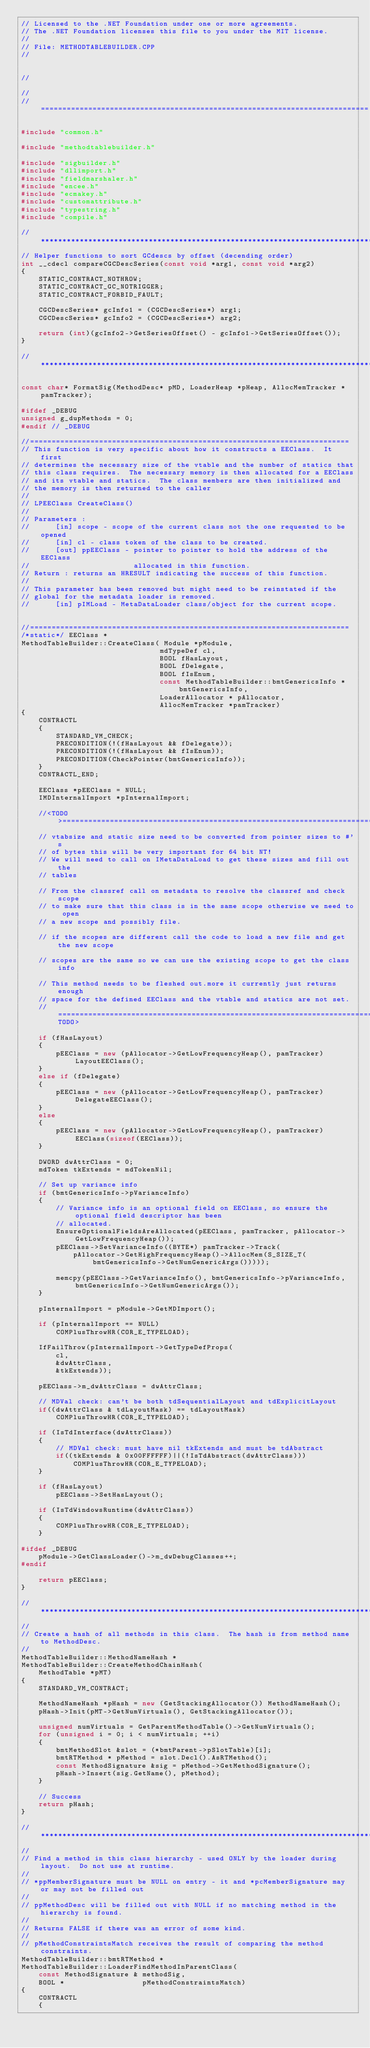Convert code to text. <code><loc_0><loc_0><loc_500><loc_500><_C++_>// Licensed to the .NET Foundation under one or more agreements.
// The .NET Foundation licenses this file to you under the MIT license.
//
// File: METHODTABLEBUILDER.CPP
//


//

//
// ============================================================================

#include "common.h"

#include "methodtablebuilder.h"

#include "sigbuilder.h"
#include "dllimport.h"
#include "fieldmarshaler.h"
#include "encee.h"
#include "ecmakey.h"
#include "customattribute.h"
#include "typestring.h"
#include "compile.h"

//*******************************************************************************
// Helper functions to sort GCdescs by offset (decending order)
int __cdecl compareCGCDescSeries(const void *arg1, const void *arg2)
{
    STATIC_CONTRACT_NOTHROW;
    STATIC_CONTRACT_GC_NOTRIGGER;
    STATIC_CONTRACT_FORBID_FAULT;

    CGCDescSeries* gcInfo1 = (CGCDescSeries*) arg1;
    CGCDescSeries* gcInfo2 = (CGCDescSeries*) arg2;

    return (int)(gcInfo2->GetSeriesOffset() - gcInfo1->GetSeriesOffset());
}

//*******************************************************************************

const char* FormatSig(MethodDesc* pMD, LoaderHeap *pHeap, AllocMemTracker *pamTracker);

#ifdef _DEBUG
unsigned g_dupMethods = 0;
#endif // _DEBUG

//==========================================================================
// This function is very specific about how it constructs a EEClass.  It first
// determines the necessary size of the vtable and the number of statics that
// this class requires.  The necessary memory is then allocated for a EEClass
// and its vtable and statics.  The class members are then initialized and
// the memory is then returned to the caller
//
// LPEEClass CreateClass()
//
// Parameters :
//      [in] scope - scope of the current class not the one requested to be opened
//      [in] cl - class token of the class to be created.
//      [out] ppEEClass - pointer to pointer to hold the address of the EEClass
//                        allocated in this function.
// Return : returns an HRESULT indicating the success of this function.
//
// This parameter has been removed but might need to be reinstated if the
// global for the metadata loader is removed.
//      [in] pIMLoad - MetaDataLoader class/object for the current scope.


//==========================================================================
/*static*/ EEClass *
MethodTableBuilder::CreateClass( Module *pModule,
                                mdTypeDef cl,
                                BOOL fHasLayout,
                                BOOL fDelegate,
                                BOOL fIsEnum,
                                const MethodTableBuilder::bmtGenericsInfo *bmtGenericsInfo,
                                LoaderAllocator * pAllocator,
                                AllocMemTracker *pamTracker)
{
    CONTRACTL
    {
        STANDARD_VM_CHECK;
        PRECONDITION(!(fHasLayout && fDelegate));
        PRECONDITION(!(fHasLayout && fIsEnum));
        PRECONDITION(CheckPointer(bmtGenericsInfo));
    }
    CONTRACTL_END;

    EEClass *pEEClass = NULL;
    IMDInternalImport *pInternalImport;

    //<TODO>============================================================================
    // vtabsize and static size need to be converted from pointer sizes to #'s
    // of bytes this will be very important for 64 bit NT!
    // We will need to call on IMetaDataLoad to get these sizes and fill out the
    // tables

    // From the classref call on metadata to resolve the classref and check scope
    // to make sure that this class is in the same scope otherwise we need to open
    // a new scope and possibly file.

    // if the scopes are different call the code to load a new file and get the new scope

    // scopes are the same so we can use the existing scope to get the class info

    // This method needs to be fleshed out.more it currently just returns enough
    // space for the defined EEClass and the vtable and statics are not set.
    //=============================================================================</TODO>

    if (fHasLayout)
    {
        pEEClass = new (pAllocator->GetLowFrequencyHeap(), pamTracker) LayoutEEClass();
    }
    else if (fDelegate)
    {
        pEEClass = new (pAllocator->GetLowFrequencyHeap(), pamTracker) DelegateEEClass();
    }
    else
    {
        pEEClass = new (pAllocator->GetLowFrequencyHeap(), pamTracker) EEClass(sizeof(EEClass));
    }

    DWORD dwAttrClass = 0;
    mdToken tkExtends = mdTokenNil;

    // Set up variance info
    if (bmtGenericsInfo->pVarianceInfo)
    {
        // Variance info is an optional field on EEClass, so ensure the optional field descriptor has been
        // allocated.
        EnsureOptionalFieldsAreAllocated(pEEClass, pamTracker, pAllocator->GetLowFrequencyHeap());
        pEEClass->SetVarianceInfo((BYTE*) pamTracker->Track(
            pAllocator->GetHighFrequencyHeap()->AllocMem(S_SIZE_T(bmtGenericsInfo->GetNumGenericArgs()))));

        memcpy(pEEClass->GetVarianceInfo(), bmtGenericsInfo->pVarianceInfo, bmtGenericsInfo->GetNumGenericArgs());
    }

    pInternalImport = pModule->GetMDImport();

    if (pInternalImport == NULL)
        COMPlusThrowHR(COR_E_TYPELOAD);

    IfFailThrow(pInternalImport->GetTypeDefProps(
        cl,
        &dwAttrClass,
        &tkExtends));

    pEEClass->m_dwAttrClass = dwAttrClass;

    // MDVal check: can't be both tdSequentialLayout and tdExplicitLayout
    if((dwAttrClass & tdLayoutMask) == tdLayoutMask)
        COMPlusThrowHR(COR_E_TYPELOAD);

    if (IsTdInterface(dwAttrClass))
    {
        // MDVal check: must have nil tkExtends and must be tdAbstract
        if((tkExtends & 0x00FFFFFF)||(!IsTdAbstract(dwAttrClass)))
            COMPlusThrowHR(COR_E_TYPELOAD);
    }

    if (fHasLayout)
        pEEClass->SetHasLayout();

    if (IsTdWindowsRuntime(dwAttrClass))
    {
        COMPlusThrowHR(COR_E_TYPELOAD);
    }

#ifdef _DEBUG
    pModule->GetClassLoader()->m_dwDebugClasses++;
#endif

    return pEEClass;
}

//*******************************************************************************
//
// Create a hash of all methods in this class.  The hash is from method name to MethodDesc.
//
MethodTableBuilder::MethodNameHash *
MethodTableBuilder::CreateMethodChainHash(
    MethodTable *pMT)
{
    STANDARD_VM_CONTRACT;

    MethodNameHash *pHash = new (GetStackingAllocator()) MethodNameHash();
    pHash->Init(pMT->GetNumVirtuals(), GetStackingAllocator());

    unsigned numVirtuals = GetParentMethodTable()->GetNumVirtuals();
    for (unsigned i = 0; i < numVirtuals; ++i)
    {
        bmtMethodSlot &slot = (*bmtParent->pSlotTable)[i];
        bmtRTMethod * pMethod = slot.Decl().AsRTMethod();
        const MethodSignature &sig = pMethod->GetMethodSignature();
        pHash->Insert(sig.GetName(), pMethod);
    }

    // Success
    return pHash;
}

//*******************************************************************************
//
// Find a method in this class hierarchy - used ONLY by the loader during layout.  Do not use at runtime.
//
// *ppMemberSignature must be NULL on entry - it and *pcMemberSignature may or may not be filled out
//
// ppMethodDesc will be filled out with NULL if no matching method in the hierarchy is found.
//
// Returns FALSE if there was an error of some kind.
//
// pMethodConstraintsMatch receives the result of comparing the method constraints.
MethodTableBuilder::bmtRTMethod *
MethodTableBuilder::LoaderFindMethodInParentClass(
    const MethodSignature & methodSig,
    BOOL *                  pMethodConstraintsMatch)
{
    CONTRACTL
    {</code> 